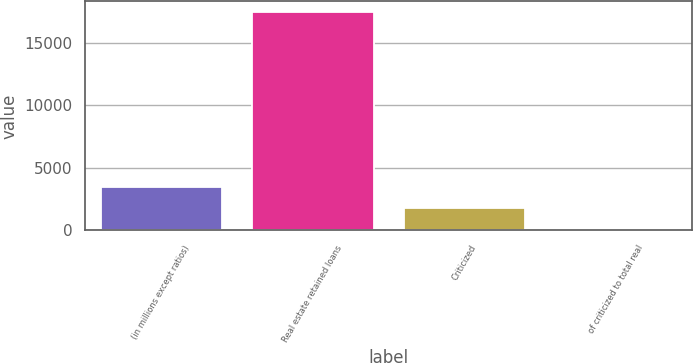Convert chart to OTSL. <chart><loc_0><loc_0><loc_500><loc_500><bar_chart><fcel>(in millions except ratios)<fcel>Real estate retained loans<fcel>Criticized<fcel>of criticized to total real<nl><fcel>3491.46<fcel>17438<fcel>1748.14<fcel>4.82<nl></chart> 